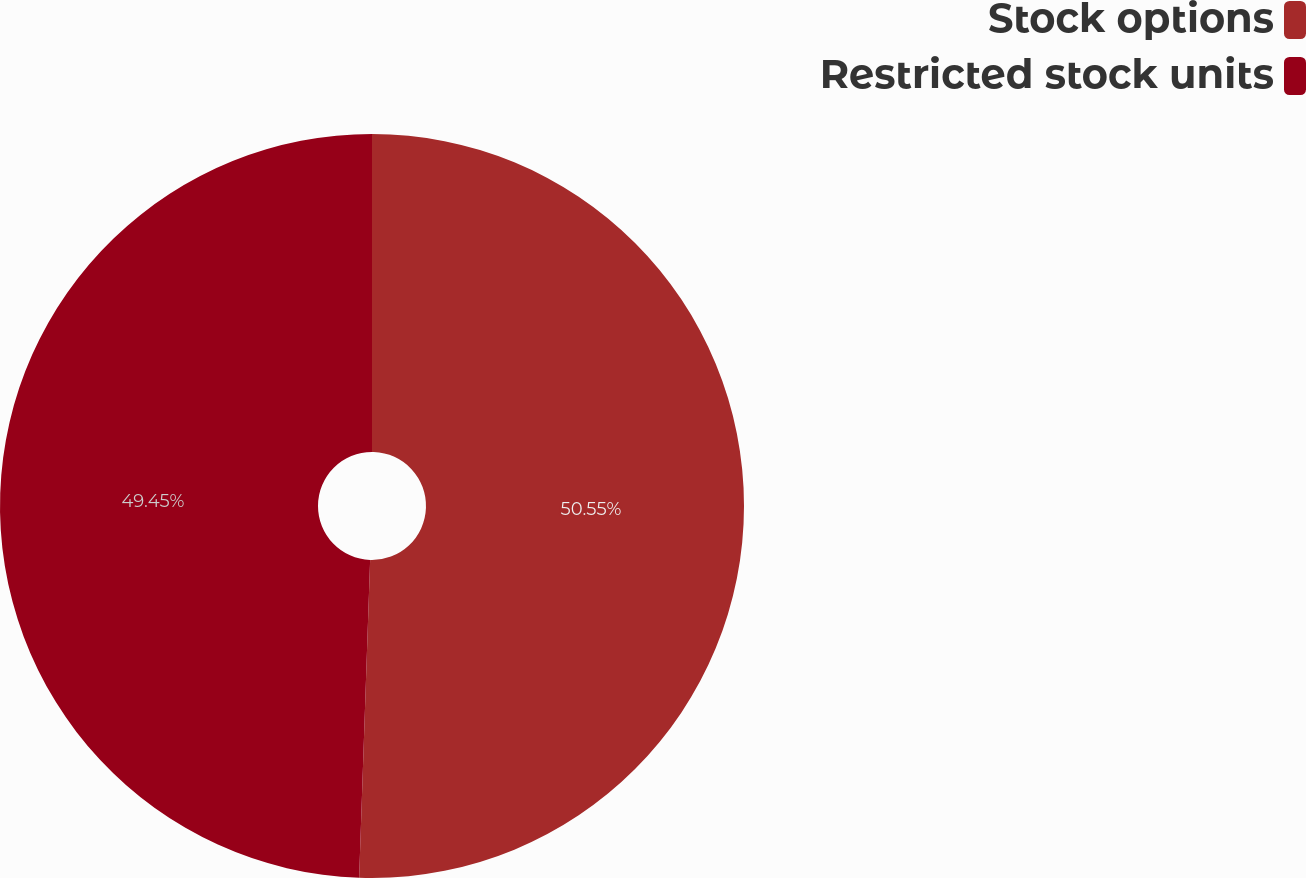Convert chart to OTSL. <chart><loc_0><loc_0><loc_500><loc_500><pie_chart><fcel>Stock options<fcel>Restricted stock units<nl><fcel>50.55%<fcel>49.45%<nl></chart> 